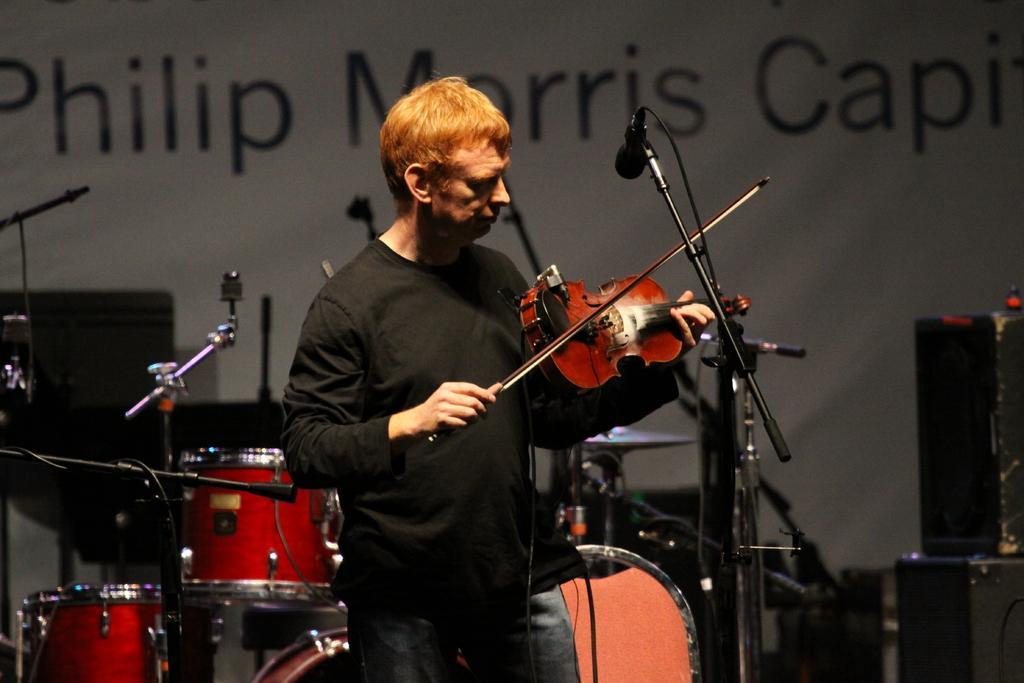Please provide a concise description of this image. In this image, we can see a person playing a musical instrument. We can also see some microphones and musical instruments. We can also see a black colored object on the right. We can see the wall with some text. 